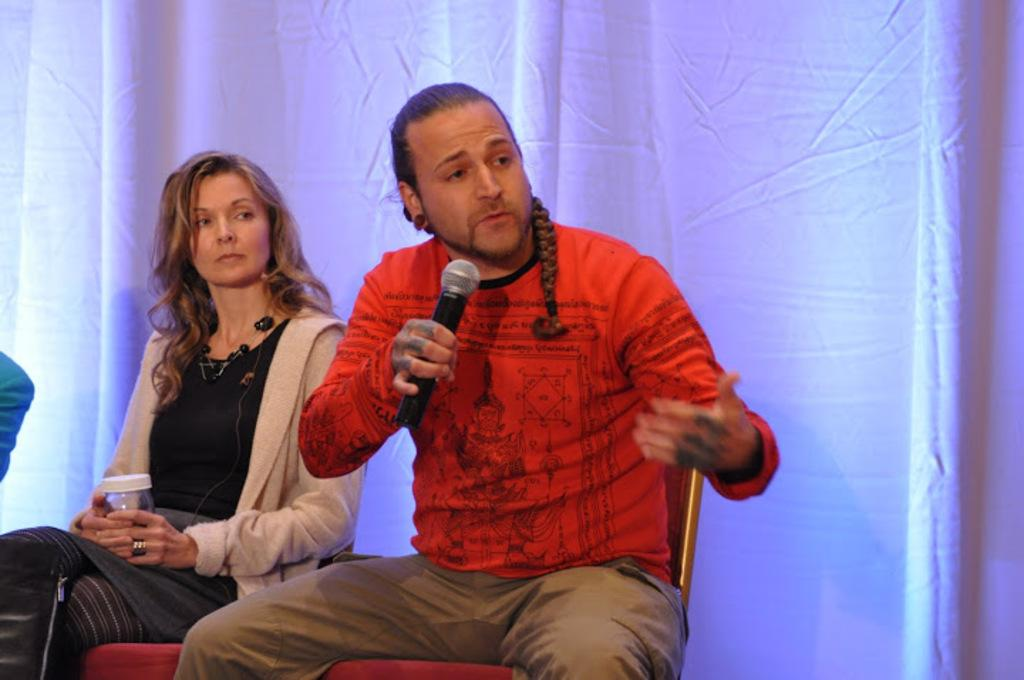How many people are in the image? There are two persons in the image. What are the persons doing in the image? The persons are sitting. Can you describe what each person is holding? One person is holding a microphone, and the other person is holding a glass. What can be seen in the background of the image? There is a cloth visible in the background. What type of ice can be seen melting in the glass held by one of the persons? There is no ice visible in the glass held by one of the persons in the image. Can you tell me how many matches are on the table in the image? There are no matches present in the image. 